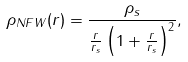<formula> <loc_0><loc_0><loc_500><loc_500>\rho _ { N F W } ( r ) = \frac { \rho _ { s } } { \frac { r } { r _ { s } } \left ( 1 + \frac { r } { r _ { s } } \right ) ^ { 2 } } ,</formula> 